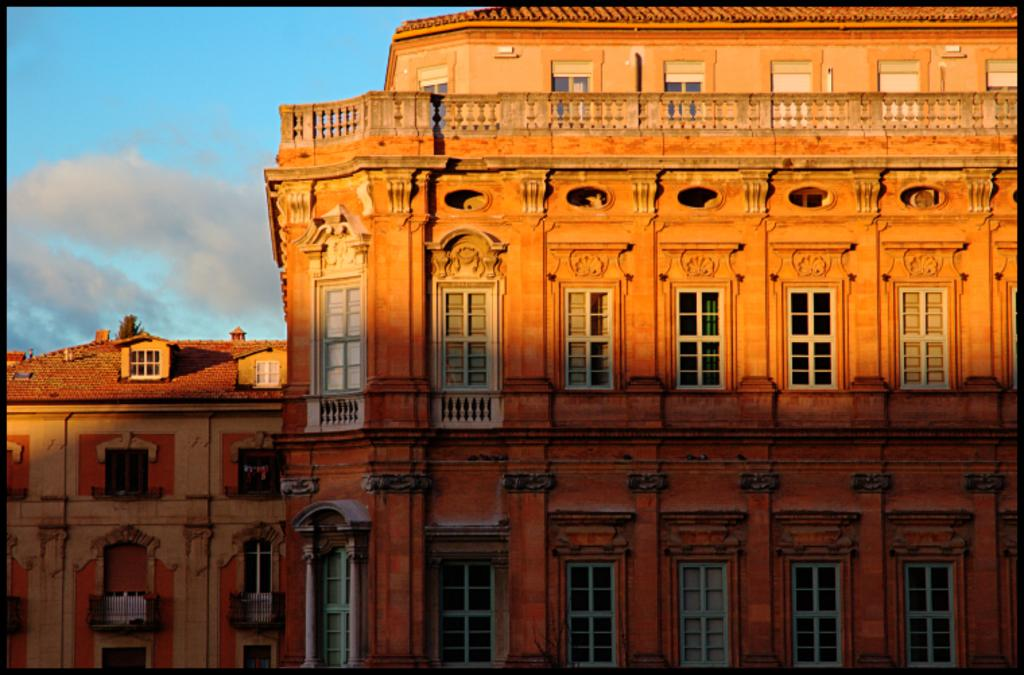What is the main subject in the center of the image? There are buildings in the center of the image. What is the condition of the sky in the image? The sky is cloudy in the image. Can you see a pig in the image? No, there is no pig present in the image. How many partners are visible in the image? There is no reference to partners in the image, so it is not possible to answer that question. 